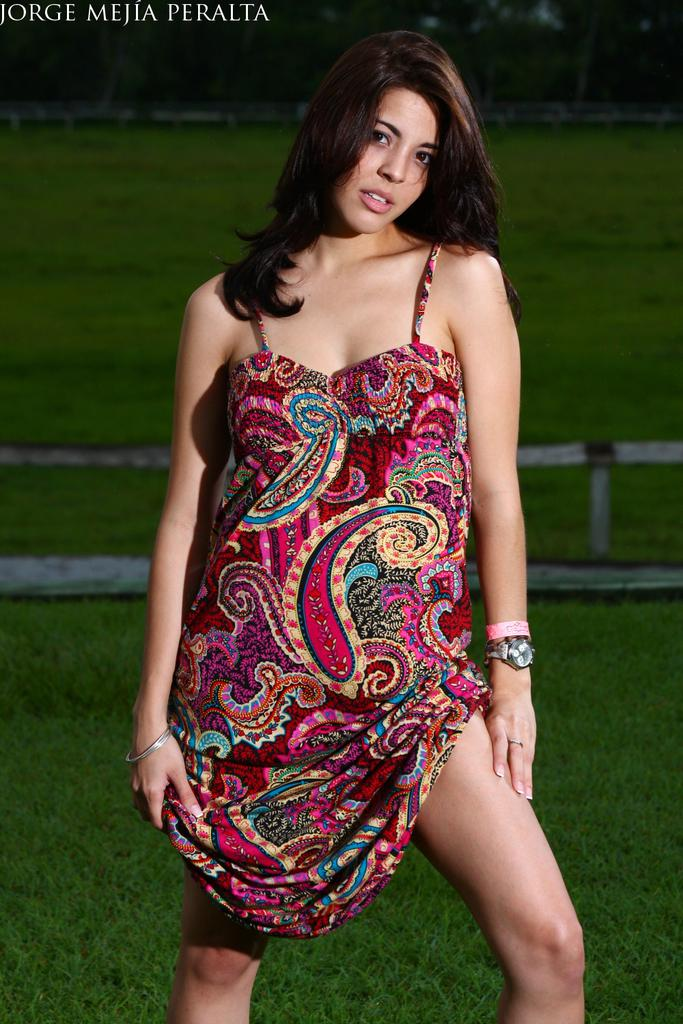What is the main subject of the image? There is a woman standing in the image. What is the ground surface like behind the woman? There is grass on the ground behind the woman. What type of vegetation can be seen at the top of the image? Trees are visible at the top of the image. What is written or displayed in the top left corner of the image? There is text in the top left corner of the image. How many clocks are hanging from the trees in the image? There are no clocks hanging from the trees in the image. What is the weight of the woman in the image? The weight of the woman cannot be determined from the image. 